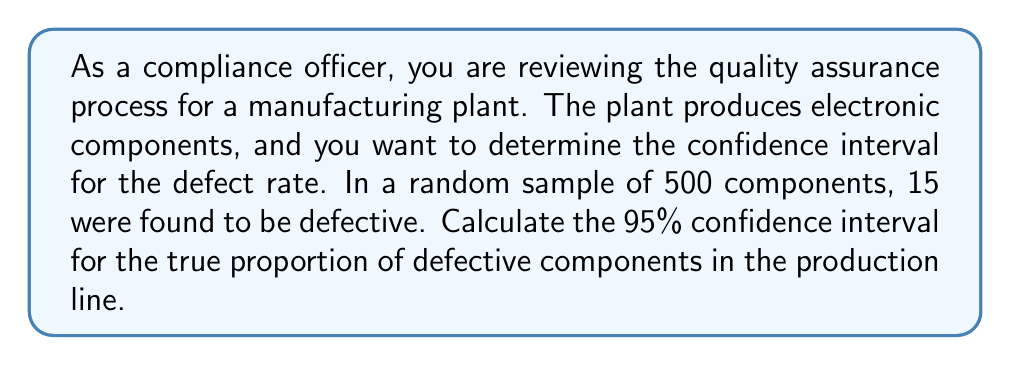Can you answer this question? To calculate the confidence interval for a proportion, we'll use the following steps:

1. Calculate the sample proportion:
   $\hat{p} = \frac{\text{number of defectives}}{\text{sample size}} = \frac{15}{500} = 0.03$

2. Calculate the standard error of the proportion:
   $SE = \sqrt{\frac{\hat{p}(1-\hat{p})}{n}} = \sqrt{\frac{0.03(1-0.03)}{500}} = \sqrt{\frac{0.0291}{500}} = 0.00762$

3. For a 95% confidence interval, we use a z-score of 1.96 (from the standard normal distribution table).

4. Calculate the margin of error:
   $\text{Margin of Error} = z \times SE = 1.96 \times 0.00762 = 0.01494$

5. Calculate the confidence interval:
   $\text{CI} = \hat{p} \pm \text{Margin of Error}$
   $\text{CI} = 0.03 \pm 0.01494$

   Lower bound: $0.03 - 0.01494 = 0.01506$
   Upper bound: $0.03 + 0.01494 = 0.04494$

Therefore, the 95% confidence interval for the true proportion of defective components is (0.01506, 0.04494).

We can interpret this as: We are 95% confident that the true proportion of defective components in the production line falls between 1.506% and 4.494%.
Answer: The 95% confidence interval for the true proportion of defective components is (0.01506, 0.04494) or (1.506%, 4.494%). 